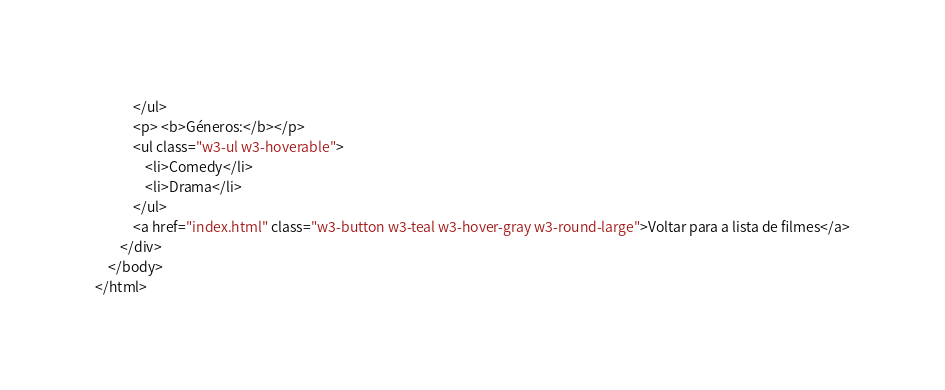<code> <loc_0><loc_0><loc_500><loc_500><_HTML_>			</ul>
            <p> <b>Géneros:</b></p>
            <ul class="w3-ul w3-hoverable">
				<li>Comedy</li>
				<li>Drama</li>
			</ul>
            <a href="index.html" class="w3-button w3-teal w3-hover-gray w3-round-large">Voltar para a lista de filmes</a>
        </div>
    </body>
</html></code> 